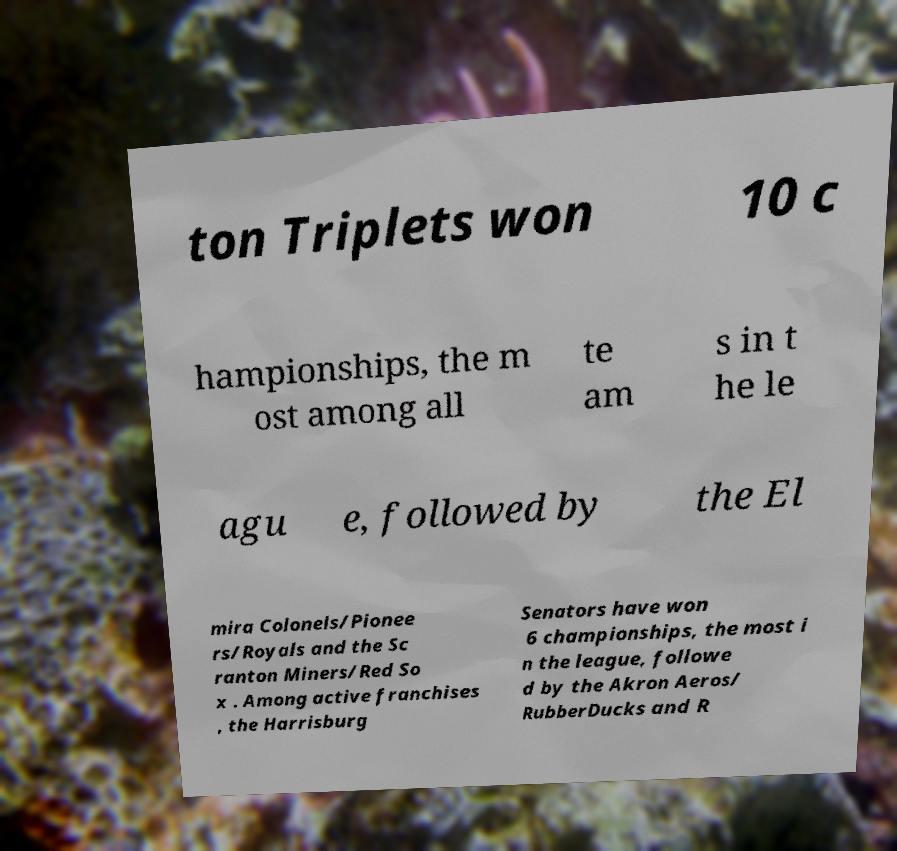Could you extract and type out the text from this image? ton Triplets won 10 c hampionships, the m ost among all te am s in t he le agu e, followed by the El mira Colonels/Pionee rs/Royals and the Sc ranton Miners/Red So x . Among active franchises , the Harrisburg Senators have won 6 championships, the most i n the league, followe d by the Akron Aeros/ RubberDucks and R 